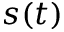Convert formula to latex. <formula><loc_0><loc_0><loc_500><loc_500>s ( t )</formula> 